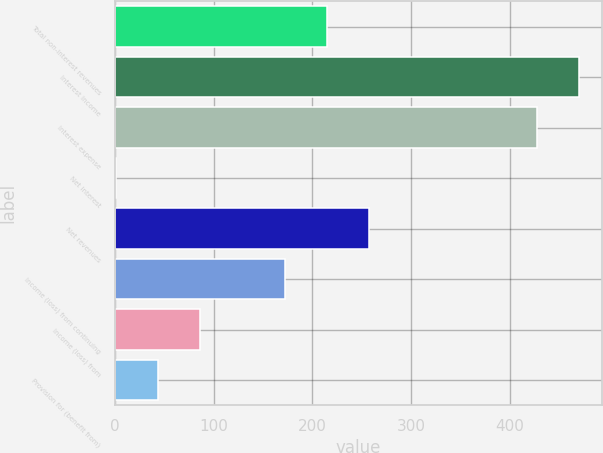Convert chart to OTSL. <chart><loc_0><loc_0><loc_500><loc_500><bar_chart><fcel>Total non-interest revenues<fcel>Interest income<fcel>Interest expense<fcel>Net interest<fcel>Net revenues<fcel>Income (loss) from continuing<fcel>Income (loss) from<fcel>Provision for (benefit from)<nl><fcel>214.5<fcel>469.7<fcel>427<fcel>1<fcel>257.2<fcel>171.8<fcel>86.4<fcel>43.7<nl></chart> 